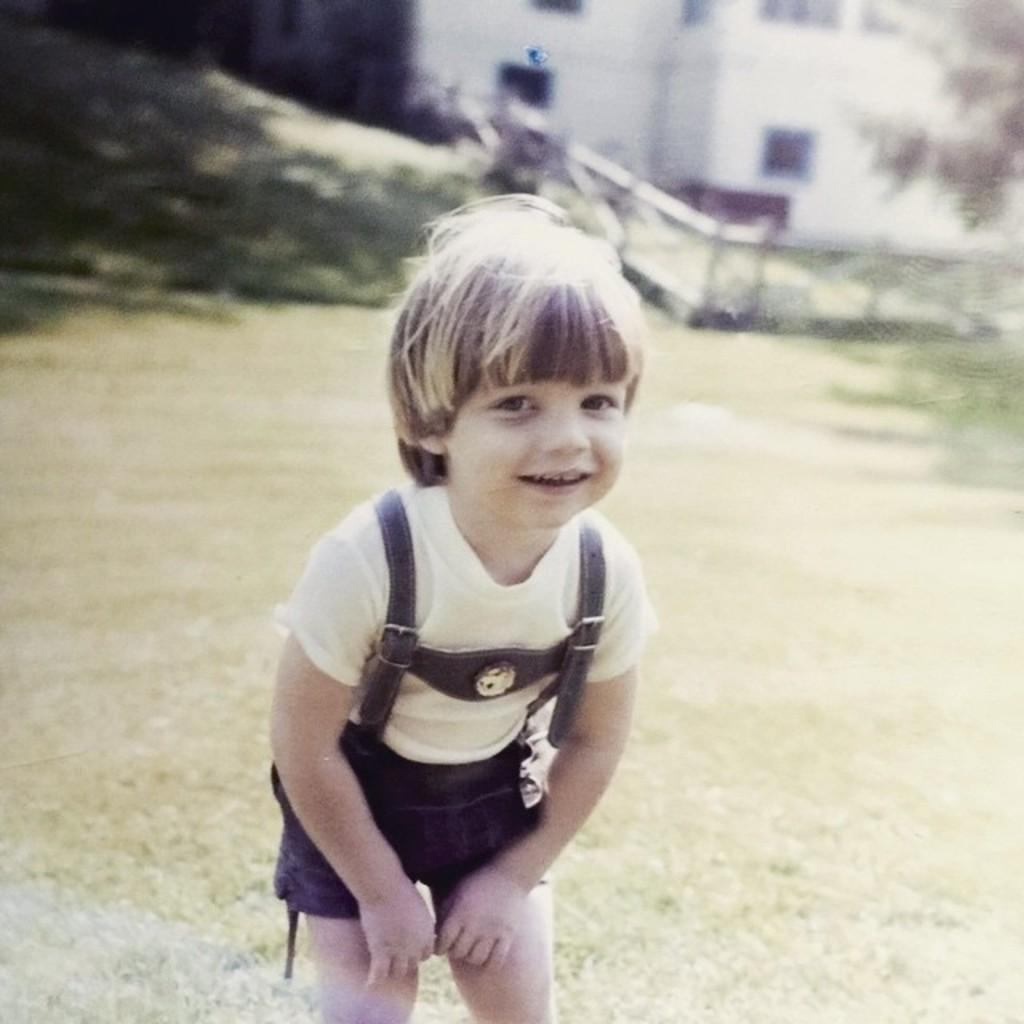What is the main subject of the image? The main subject of the image is a small kid. Where is the kid located in the image? The kid is standing on the grass. Who or what is the kid looking at? The kid is looking at someone. What is the kid's facial expression in the image? The kid is smiling. What type of drum is the goat playing in the image? There is no goat or drum present in the image; it features a small kid standing on the grass and smiling. 